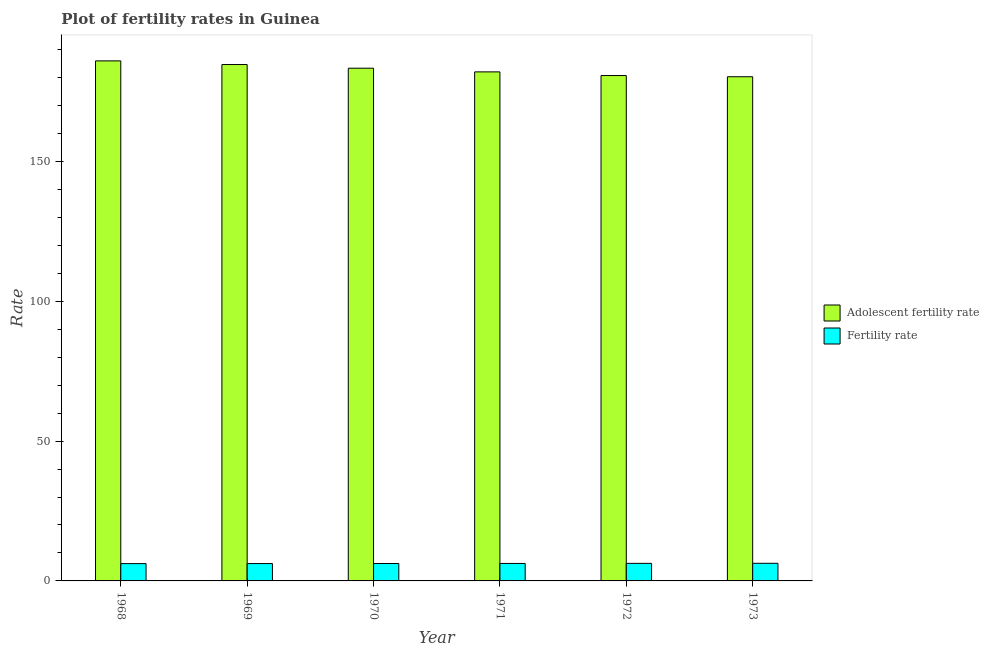How many different coloured bars are there?
Offer a terse response. 2. Are the number of bars per tick equal to the number of legend labels?
Offer a very short reply. Yes. Are the number of bars on each tick of the X-axis equal?
Offer a very short reply. Yes. How many bars are there on the 5th tick from the left?
Keep it short and to the point. 2. How many bars are there on the 2nd tick from the right?
Your answer should be compact. 2. What is the label of the 3rd group of bars from the left?
Ensure brevity in your answer.  1970. What is the fertility rate in 1970?
Ensure brevity in your answer.  6.22. Across all years, what is the maximum adolescent fertility rate?
Give a very brief answer. 185.98. Across all years, what is the minimum fertility rate?
Your response must be concise. 6.19. In which year was the adolescent fertility rate maximum?
Offer a terse response. 1968. In which year was the fertility rate minimum?
Keep it short and to the point. 1968. What is the total adolescent fertility rate in the graph?
Offer a very short reply. 1097.09. What is the difference between the adolescent fertility rate in 1972 and that in 1973?
Ensure brevity in your answer.  0.43. What is the difference between the fertility rate in 1971 and the adolescent fertility rate in 1972?
Provide a succinct answer. -0.03. What is the average fertility rate per year?
Provide a short and direct response. 6.24. In the year 1973, what is the difference between the fertility rate and adolescent fertility rate?
Provide a short and direct response. 0. In how many years, is the adolescent fertility rate greater than 130?
Give a very brief answer. 6. What is the ratio of the fertility rate in 1968 to that in 1969?
Provide a succinct answer. 1. Is the adolescent fertility rate in 1969 less than that in 1972?
Your answer should be compact. No. What is the difference between the highest and the second highest fertility rate?
Offer a terse response. 0.03. What is the difference between the highest and the lowest fertility rate?
Give a very brief answer. 0.12. In how many years, is the adolescent fertility rate greater than the average adolescent fertility rate taken over all years?
Offer a terse response. 3. What does the 2nd bar from the left in 1973 represents?
Offer a very short reply. Fertility rate. What does the 2nd bar from the right in 1970 represents?
Give a very brief answer. Adolescent fertility rate. Are all the bars in the graph horizontal?
Your answer should be very brief. No. How many years are there in the graph?
Your response must be concise. 6. Are the values on the major ticks of Y-axis written in scientific E-notation?
Your answer should be very brief. No. Does the graph contain any zero values?
Offer a very short reply. No. How many legend labels are there?
Give a very brief answer. 2. What is the title of the graph?
Give a very brief answer. Plot of fertility rates in Guinea. What is the label or title of the Y-axis?
Provide a short and direct response. Rate. What is the Rate of Adolescent fertility rate in 1968?
Give a very brief answer. 185.98. What is the Rate of Fertility rate in 1968?
Your answer should be very brief. 6.19. What is the Rate of Adolescent fertility rate in 1969?
Ensure brevity in your answer.  184.67. What is the Rate of Fertility rate in 1969?
Provide a short and direct response. 6.21. What is the Rate in Adolescent fertility rate in 1970?
Offer a very short reply. 183.36. What is the Rate of Fertility rate in 1970?
Your answer should be compact. 6.22. What is the Rate in Adolescent fertility rate in 1971?
Provide a short and direct response. 182.05. What is the Rate in Fertility rate in 1971?
Your answer should be very brief. 6.25. What is the Rate of Adolescent fertility rate in 1972?
Make the answer very short. 180.73. What is the Rate of Fertility rate in 1972?
Your response must be concise. 6.28. What is the Rate of Adolescent fertility rate in 1973?
Your response must be concise. 180.3. What is the Rate in Fertility rate in 1973?
Ensure brevity in your answer.  6.31. Across all years, what is the maximum Rate in Adolescent fertility rate?
Provide a succinct answer. 185.98. Across all years, what is the maximum Rate in Fertility rate?
Provide a short and direct response. 6.31. Across all years, what is the minimum Rate of Adolescent fertility rate?
Your answer should be very brief. 180.3. Across all years, what is the minimum Rate in Fertility rate?
Provide a succinct answer. 6.19. What is the total Rate of Adolescent fertility rate in the graph?
Your response must be concise. 1097.09. What is the total Rate of Fertility rate in the graph?
Make the answer very short. 37.45. What is the difference between the Rate of Adolescent fertility rate in 1968 and that in 1969?
Your answer should be very brief. 1.31. What is the difference between the Rate in Fertility rate in 1968 and that in 1969?
Make the answer very short. -0.02. What is the difference between the Rate of Adolescent fertility rate in 1968 and that in 1970?
Keep it short and to the point. 2.62. What is the difference between the Rate of Fertility rate in 1968 and that in 1970?
Your response must be concise. -0.04. What is the difference between the Rate in Adolescent fertility rate in 1968 and that in 1971?
Provide a succinct answer. 3.93. What is the difference between the Rate in Fertility rate in 1968 and that in 1971?
Make the answer very short. -0.06. What is the difference between the Rate in Adolescent fertility rate in 1968 and that in 1972?
Offer a very short reply. 5.24. What is the difference between the Rate of Fertility rate in 1968 and that in 1972?
Provide a short and direct response. -0.09. What is the difference between the Rate of Adolescent fertility rate in 1968 and that in 1973?
Keep it short and to the point. 5.67. What is the difference between the Rate in Fertility rate in 1968 and that in 1973?
Keep it short and to the point. -0.12. What is the difference between the Rate in Adolescent fertility rate in 1969 and that in 1970?
Give a very brief answer. 1.31. What is the difference between the Rate in Fertility rate in 1969 and that in 1970?
Provide a short and direct response. -0.02. What is the difference between the Rate in Adolescent fertility rate in 1969 and that in 1971?
Give a very brief answer. 2.62. What is the difference between the Rate of Fertility rate in 1969 and that in 1971?
Give a very brief answer. -0.04. What is the difference between the Rate of Adolescent fertility rate in 1969 and that in 1972?
Your response must be concise. 3.93. What is the difference between the Rate in Fertility rate in 1969 and that in 1972?
Make the answer very short. -0.07. What is the difference between the Rate of Adolescent fertility rate in 1969 and that in 1973?
Provide a short and direct response. 4.36. What is the difference between the Rate of Fertility rate in 1969 and that in 1973?
Your response must be concise. -0.1. What is the difference between the Rate in Adolescent fertility rate in 1970 and that in 1971?
Provide a succinct answer. 1.31. What is the difference between the Rate in Fertility rate in 1970 and that in 1971?
Make the answer very short. -0.02. What is the difference between the Rate in Adolescent fertility rate in 1970 and that in 1972?
Make the answer very short. 2.62. What is the difference between the Rate of Fertility rate in 1970 and that in 1972?
Offer a very short reply. -0.05. What is the difference between the Rate in Adolescent fertility rate in 1970 and that in 1973?
Make the answer very short. 3.05. What is the difference between the Rate of Fertility rate in 1970 and that in 1973?
Provide a succinct answer. -0.08. What is the difference between the Rate in Adolescent fertility rate in 1971 and that in 1972?
Your answer should be compact. 1.31. What is the difference between the Rate of Fertility rate in 1971 and that in 1972?
Provide a short and direct response. -0.03. What is the difference between the Rate in Adolescent fertility rate in 1971 and that in 1973?
Your response must be concise. 1.74. What is the difference between the Rate of Fertility rate in 1971 and that in 1973?
Give a very brief answer. -0.06. What is the difference between the Rate in Adolescent fertility rate in 1972 and that in 1973?
Make the answer very short. 0.43. What is the difference between the Rate in Fertility rate in 1972 and that in 1973?
Offer a very short reply. -0.03. What is the difference between the Rate in Adolescent fertility rate in 1968 and the Rate in Fertility rate in 1969?
Keep it short and to the point. 179.77. What is the difference between the Rate in Adolescent fertility rate in 1968 and the Rate in Fertility rate in 1970?
Give a very brief answer. 179.75. What is the difference between the Rate of Adolescent fertility rate in 1968 and the Rate of Fertility rate in 1971?
Offer a very short reply. 179.73. What is the difference between the Rate in Adolescent fertility rate in 1968 and the Rate in Fertility rate in 1972?
Your answer should be very brief. 179.7. What is the difference between the Rate in Adolescent fertility rate in 1968 and the Rate in Fertility rate in 1973?
Offer a terse response. 179.67. What is the difference between the Rate of Adolescent fertility rate in 1969 and the Rate of Fertility rate in 1970?
Your answer should be compact. 178.44. What is the difference between the Rate in Adolescent fertility rate in 1969 and the Rate in Fertility rate in 1971?
Provide a succinct answer. 178.42. What is the difference between the Rate of Adolescent fertility rate in 1969 and the Rate of Fertility rate in 1972?
Offer a terse response. 178.39. What is the difference between the Rate in Adolescent fertility rate in 1969 and the Rate in Fertility rate in 1973?
Your response must be concise. 178.36. What is the difference between the Rate in Adolescent fertility rate in 1970 and the Rate in Fertility rate in 1971?
Provide a short and direct response. 177.11. What is the difference between the Rate of Adolescent fertility rate in 1970 and the Rate of Fertility rate in 1972?
Offer a very short reply. 177.08. What is the difference between the Rate in Adolescent fertility rate in 1970 and the Rate in Fertility rate in 1973?
Provide a short and direct response. 177.05. What is the difference between the Rate of Adolescent fertility rate in 1971 and the Rate of Fertility rate in 1972?
Provide a succinct answer. 175.77. What is the difference between the Rate in Adolescent fertility rate in 1971 and the Rate in Fertility rate in 1973?
Provide a succinct answer. 175.74. What is the difference between the Rate in Adolescent fertility rate in 1972 and the Rate in Fertility rate in 1973?
Provide a short and direct response. 174.43. What is the average Rate of Adolescent fertility rate per year?
Provide a succinct answer. 182.85. What is the average Rate in Fertility rate per year?
Make the answer very short. 6.24. In the year 1968, what is the difference between the Rate in Adolescent fertility rate and Rate in Fertility rate?
Your response must be concise. 179.79. In the year 1969, what is the difference between the Rate in Adolescent fertility rate and Rate in Fertility rate?
Offer a terse response. 178.46. In the year 1970, what is the difference between the Rate in Adolescent fertility rate and Rate in Fertility rate?
Give a very brief answer. 177.13. In the year 1971, what is the difference between the Rate of Adolescent fertility rate and Rate of Fertility rate?
Provide a succinct answer. 175.8. In the year 1972, what is the difference between the Rate of Adolescent fertility rate and Rate of Fertility rate?
Keep it short and to the point. 174.46. In the year 1973, what is the difference between the Rate of Adolescent fertility rate and Rate of Fertility rate?
Your answer should be compact. 174. What is the ratio of the Rate in Adolescent fertility rate in 1968 to that in 1969?
Offer a terse response. 1.01. What is the ratio of the Rate in Adolescent fertility rate in 1968 to that in 1970?
Your answer should be compact. 1.01. What is the ratio of the Rate in Fertility rate in 1968 to that in 1970?
Provide a short and direct response. 0.99. What is the ratio of the Rate of Adolescent fertility rate in 1968 to that in 1971?
Give a very brief answer. 1.02. What is the ratio of the Rate in Adolescent fertility rate in 1968 to that in 1973?
Give a very brief answer. 1.03. What is the ratio of the Rate of Fertility rate in 1968 to that in 1973?
Provide a succinct answer. 0.98. What is the ratio of the Rate in Adolescent fertility rate in 1969 to that in 1970?
Keep it short and to the point. 1.01. What is the ratio of the Rate in Adolescent fertility rate in 1969 to that in 1971?
Your response must be concise. 1.01. What is the ratio of the Rate of Fertility rate in 1969 to that in 1971?
Make the answer very short. 0.99. What is the ratio of the Rate of Adolescent fertility rate in 1969 to that in 1972?
Your answer should be very brief. 1.02. What is the ratio of the Rate in Adolescent fertility rate in 1969 to that in 1973?
Ensure brevity in your answer.  1.02. What is the ratio of the Rate of Fertility rate in 1969 to that in 1973?
Your response must be concise. 0.98. What is the ratio of the Rate in Adolescent fertility rate in 1970 to that in 1971?
Your response must be concise. 1.01. What is the ratio of the Rate of Adolescent fertility rate in 1970 to that in 1972?
Your answer should be compact. 1.01. What is the ratio of the Rate of Fertility rate in 1970 to that in 1972?
Make the answer very short. 0.99. What is the ratio of the Rate in Adolescent fertility rate in 1970 to that in 1973?
Give a very brief answer. 1.02. What is the ratio of the Rate of Fertility rate in 1970 to that in 1973?
Provide a short and direct response. 0.99. What is the ratio of the Rate of Adolescent fertility rate in 1971 to that in 1972?
Make the answer very short. 1.01. What is the ratio of the Rate of Adolescent fertility rate in 1971 to that in 1973?
Keep it short and to the point. 1.01. What is the ratio of the Rate of Fertility rate in 1971 to that in 1973?
Give a very brief answer. 0.99. What is the ratio of the Rate in Adolescent fertility rate in 1972 to that in 1973?
Give a very brief answer. 1. What is the ratio of the Rate of Fertility rate in 1972 to that in 1973?
Your response must be concise. 1. What is the difference between the highest and the second highest Rate in Adolescent fertility rate?
Your response must be concise. 1.31. What is the difference between the highest and the second highest Rate of Fertility rate?
Your answer should be compact. 0.03. What is the difference between the highest and the lowest Rate in Adolescent fertility rate?
Give a very brief answer. 5.67. What is the difference between the highest and the lowest Rate in Fertility rate?
Your response must be concise. 0.12. 